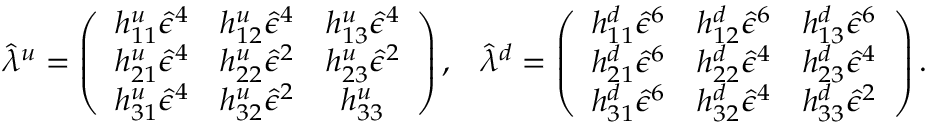<formula> <loc_0><loc_0><loc_500><loc_500>\hat { \lambda } ^ { u } = \left ( \begin{array} { c c c } { { h _ { 1 1 } ^ { u } \hat { \epsilon } ^ { 4 } } } & { { h _ { 1 2 } ^ { u } \hat { \epsilon } ^ { 4 } } } & { { h _ { 1 3 } ^ { u } \hat { \epsilon } ^ { 4 } } } \\ { { h _ { 2 1 } ^ { u } \hat { \epsilon } ^ { 4 } } } & { { h _ { 2 2 } ^ { u } \hat { \epsilon } ^ { 2 } } } & { { h _ { 2 3 } ^ { u } \hat { \epsilon } ^ { 2 } } } \\ { { h _ { 3 1 } ^ { u } \hat { \epsilon } ^ { 4 } } } & { { h _ { 3 2 } ^ { u } \hat { \epsilon } ^ { 2 } } } & { { h _ { 3 3 } ^ { u } } } \end{array} \right ) , \, \hat { \lambda } ^ { d } = \left ( \begin{array} { c c c } { { h _ { 1 1 } ^ { d } \hat { \epsilon } ^ { 6 } } } & { { h _ { 1 2 } ^ { d } \hat { \epsilon } ^ { 6 } } } & { { h _ { 1 3 } ^ { d } \hat { \epsilon } ^ { 6 } } } \\ { { h _ { 2 1 } ^ { d } \hat { \epsilon } ^ { 6 } } } & { { h _ { 2 2 } ^ { d } \hat { \epsilon } ^ { 4 } } } & { { h _ { 2 3 } ^ { d } \hat { \epsilon } ^ { 4 } } } \\ { { h _ { 3 1 } ^ { d } \hat { \epsilon } ^ { 6 } } } & { { h _ { 3 2 } ^ { d } \hat { \epsilon } ^ { 4 } } } & { { h _ { 3 3 } ^ { d } \hat { \epsilon } ^ { 2 } } } \end{array} \right ) .</formula> 